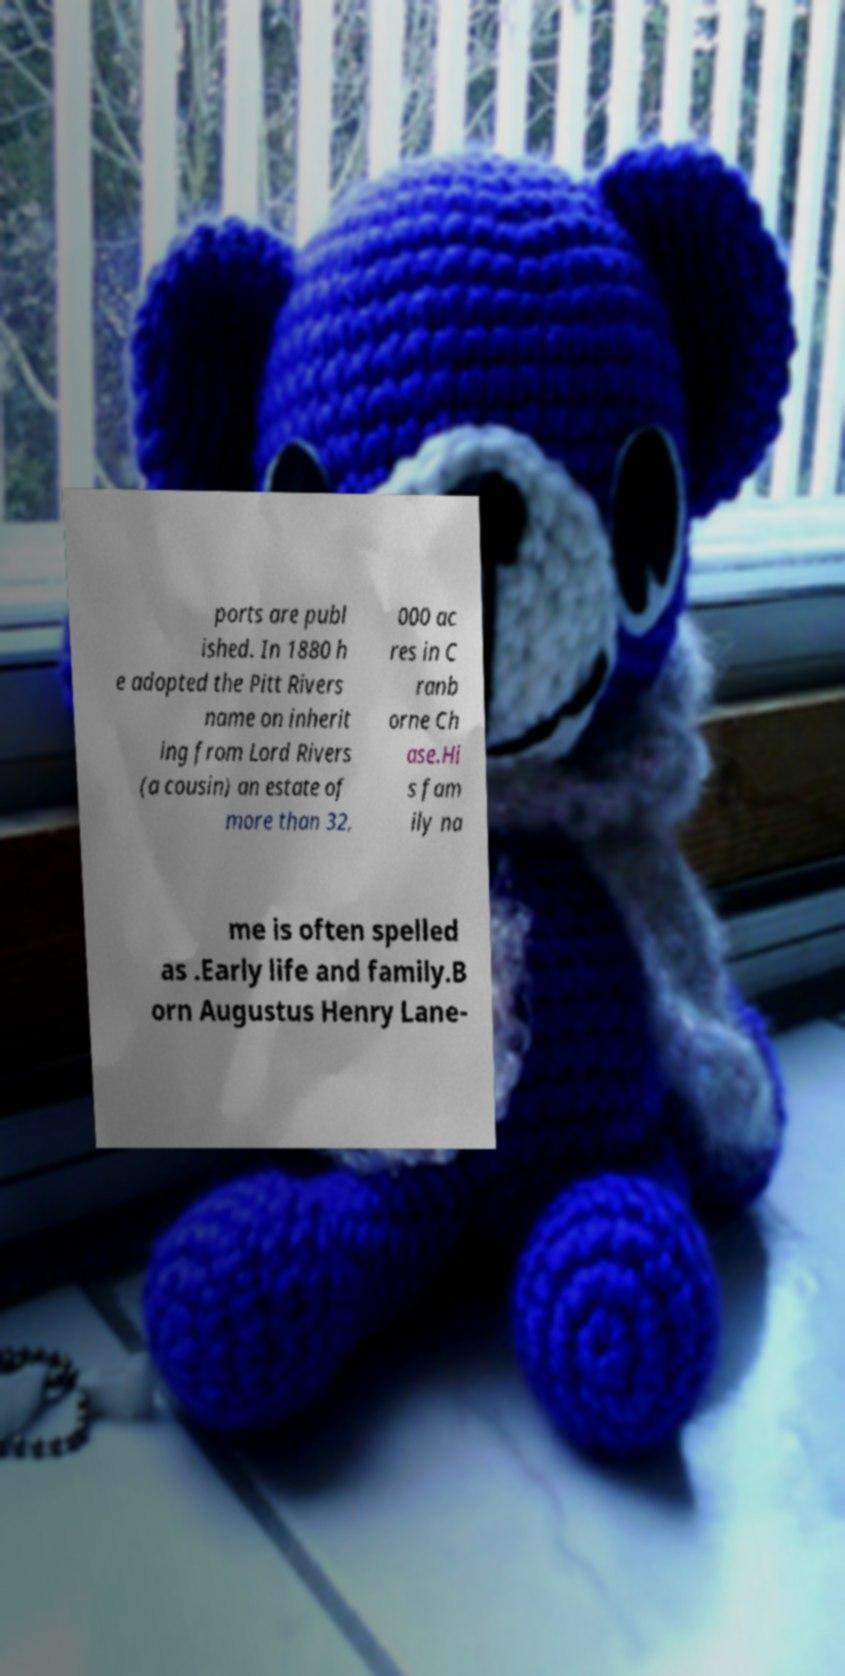There's text embedded in this image that I need extracted. Can you transcribe it verbatim? ports are publ ished. In 1880 h e adopted the Pitt Rivers name on inherit ing from Lord Rivers (a cousin) an estate of more than 32, 000 ac res in C ranb orne Ch ase.Hi s fam ily na me is often spelled as .Early life and family.B orn Augustus Henry Lane- 